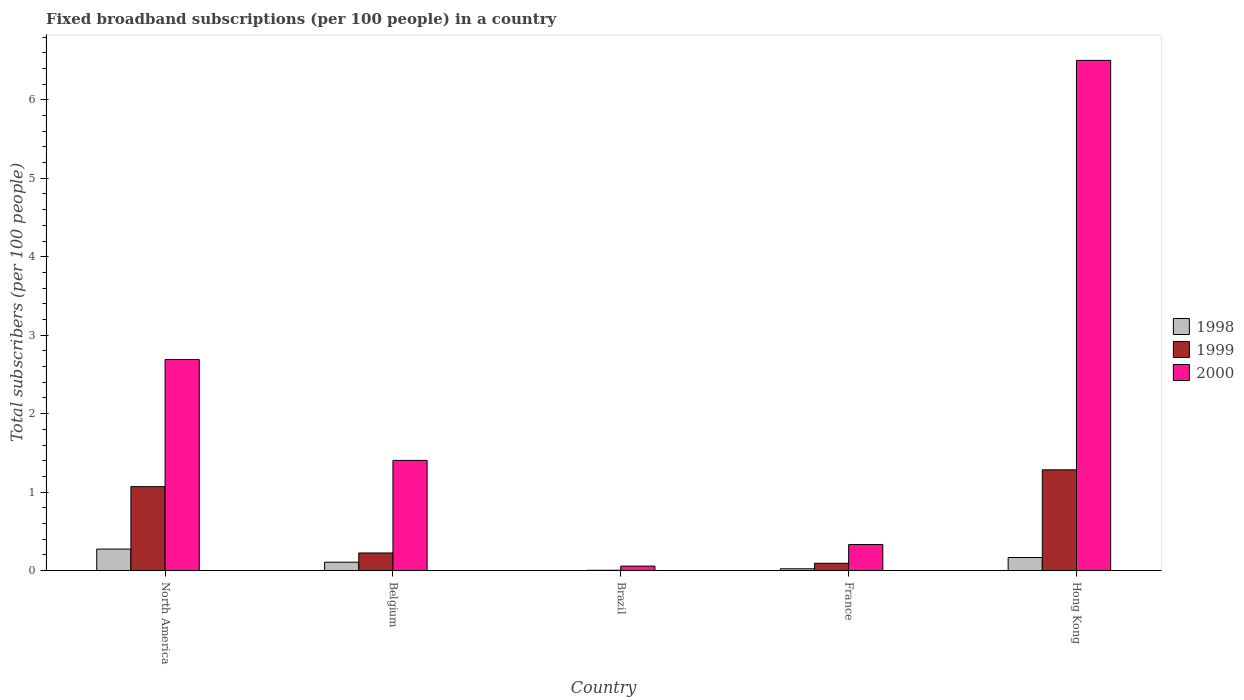How many different coloured bars are there?
Provide a short and direct response. 3. Are the number of bars per tick equal to the number of legend labels?
Your response must be concise. Yes. How many bars are there on the 4th tick from the left?
Your answer should be compact. 3. How many bars are there on the 4th tick from the right?
Provide a succinct answer. 3. What is the label of the 5th group of bars from the left?
Ensure brevity in your answer.  Hong Kong. In how many cases, is the number of bars for a given country not equal to the number of legend labels?
Ensure brevity in your answer.  0. What is the number of broadband subscriptions in 1999 in France?
Your answer should be very brief. 0.09. Across all countries, what is the maximum number of broadband subscriptions in 1998?
Your response must be concise. 0.27. Across all countries, what is the minimum number of broadband subscriptions in 2000?
Your response must be concise. 0.06. In which country was the number of broadband subscriptions in 1999 maximum?
Ensure brevity in your answer.  Hong Kong. What is the total number of broadband subscriptions in 1999 in the graph?
Make the answer very short. 2.68. What is the difference between the number of broadband subscriptions in 1998 in Belgium and that in North America?
Give a very brief answer. -0.17. What is the difference between the number of broadband subscriptions in 1998 in France and the number of broadband subscriptions in 2000 in Hong Kong?
Give a very brief answer. -6.48. What is the average number of broadband subscriptions in 2000 per country?
Give a very brief answer. 2.2. What is the difference between the number of broadband subscriptions of/in 1998 and number of broadband subscriptions of/in 1999 in North America?
Offer a terse response. -0.8. What is the ratio of the number of broadband subscriptions in 1998 in France to that in Hong Kong?
Provide a short and direct response. 0.14. Is the number of broadband subscriptions in 1999 in Belgium less than that in Brazil?
Offer a very short reply. No. What is the difference between the highest and the second highest number of broadband subscriptions in 2000?
Your response must be concise. -1.29. What is the difference between the highest and the lowest number of broadband subscriptions in 1999?
Keep it short and to the point. 1.28. What does the 2nd bar from the left in Hong Kong represents?
Provide a succinct answer. 1999. How many bars are there?
Your answer should be compact. 15. Are all the bars in the graph horizontal?
Ensure brevity in your answer.  No. How many countries are there in the graph?
Provide a short and direct response. 5. Does the graph contain grids?
Ensure brevity in your answer.  No. Where does the legend appear in the graph?
Provide a short and direct response. Center right. What is the title of the graph?
Your answer should be compact. Fixed broadband subscriptions (per 100 people) in a country. Does "1969" appear as one of the legend labels in the graph?
Keep it short and to the point. No. What is the label or title of the X-axis?
Offer a terse response. Country. What is the label or title of the Y-axis?
Your response must be concise. Total subscribers (per 100 people). What is the Total subscribers (per 100 people) in 1998 in North America?
Offer a very short reply. 0.27. What is the Total subscribers (per 100 people) of 1999 in North America?
Your answer should be very brief. 1.07. What is the Total subscribers (per 100 people) of 2000 in North America?
Your answer should be very brief. 2.69. What is the Total subscribers (per 100 people) in 1998 in Belgium?
Ensure brevity in your answer.  0.11. What is the Total subscribers (per 100 people) of 1999 in Belgium?
Your answer should be very brief. 0.22. What is the Total subscribers (per 100 people) of 2000 in Belgium?
Provide a short and direct response. 1.4. What is the Total subscribers (per 100 people) of 1998 in Brazil?
Your answer should be very brief. 0. What is the Total subscribers (per 100 people) in 1999 in Brazil?
Keep it short and to the point. 0. What is the Total subscribers (per 100 people) of 2000 in Brazil?
Your answer should be compact. 0.06. What is the Total subscribers (per 100 people) in 1998 in France?
Offer a very short reply. 0.02. What is the Total subscribers (per 100 people) in 1999 in France?
Offer a very short reply. 0.09. What is the Total subscribers (per 100 people) of 2000 in France?
Offer a terse response. 0.33. What is the Total subscribers (per 100 people) in 1998 in Hong Kong?
Ensure brevity in your answer.  0.17. What is the Total subscribers (per 100 people) in 1999 in Hong Kong?
Ensure brevity in your answer.  1.28. What is the Total subscribers (per 100 people) of 2000 in Hong Kong?
Provide a succinct answer. 6.5. Across all countries, what is the maximum Total subscribers (per 100 people) in 1998?
Give a very brief answer. 0.27. Across all countries, what is the maximum Total subscribers (per 100 people) in 1999?
Ensure brevity in your answer.  1.28. Across all countries, what is the maximum Total subscribers (per 100 people) in 2000?
Keep it short and to the point. 6.5. Across all countries, what is the minimum Total subscribers (per 100 people) in 1998?
Ensure brevity in your answer.  0. Across all countries, what is the minimum Total subscribers (per 100 people) of 1999?
Provide a short and direct response. 0. Across all countries, what is the minimum Total subscribers (per 100 people) in 2000?
Offer a terse response. 0.06. What is the total Total subscribers (per 100 people) of 1998 in the graph?
Offer a very short reply. 0.57. What is the total Total subscribers (per 100 people) in 1999 in the graph?
Your answer should be compact. 2.68. What is the total Total subscribers (per 100 people) of 2000 in the graph?
Provide a short and direct response. 10.99. What is the difference between the Total subscribers (per 100 people) in 1998 in North America and that in Belgium?
Provide a succinct answer. 0.17. What is the difference between the Total subscribers (per 100 people) of 1999 in North America and that in Belgium?
Make the answer very short. 0.85. What is the difference between the Total subscribers (per 100 people) of 2000 in North America and that in Belgium?
Make the answer very short. 1.29. What is the difference between the Total subscribers (per 100 people) in 1998 in North America and that in Brazil?
Your response must be concise. 0.27. What is the difference between the Total subscribers (per 100 people) of 1999 in North America and that in Brazil?
Provide a short and direct response. 1.07. What is the difference between the Total subscribers (per 100 people) of 2000 in North America and that in Brazil?
Your answer should be compact. 2.63. What is the difference between the Total subscribers (per 100 people) in 1998 in North America and that in France?
Give a very brief answer. 0.25. What is the difference between the Total subscribers (per 100 people) in 1999 in North America and that in France?
Your answer should be compact. 0.98. What is the difference between the Total subscribers (per 100 people) in 2000 in North America and that in France?
Ensure brevity in your answer.  2.36. What is the difference between the Total subscribers (per 100 people) in 1998 in North America and that in Hong Kong?
Give a very brief answer. 0.11. What is the difference between the Total subscribers (per 100 people) of 1999 in North America and that in Hong Kong?
Keep it short and to the point. -0.21. What is the difference between the Total subscribers (per 100 people) of 2000 in North America and that in Hong Kong?
Offer a terse response. -3.81. What is the difference between the Total subscribers (per 100 people) in 1998 in Belgium and that in Brazil?
Your answer should be compact. 0.11. What is the difference between the Total subscribers (per 100 people) in 1999 in Belgium and that in Brazil?
Ensure brevity in your answer.  0.22. What is the difference between the Total subscribers (per 100 people) in 2000 in Belgium and that in Brazil?
Your answer should be compact. 1.35. What is the difference between the Total subscribers (per 100 people) in 1998 in Belgium and that in France?
Ensure brevity in your answer.  0.08. What is the difference between the Total subscribers (per 100 people) of 1999 in Belgium and that in France?
Your answer should be compact. 0.13. What is the difference between the Total subscribers (per 100 people) of 2000 in Belgium and that in France?
Your answer should be very brief. 1.07. What is the difference between the Total subscribers (per 100 people) of 1998 in Belgium and that in Hong Kong?
Make the answer very short. -0.06. What is the difference between the Total subscribers (per 100 people) of 1999 in Belgium and that in Hong Kong?
Give a very brief answer. -1.06. What is the difference between the Total subscribers (per 100 people) of 2000 in Belgium and that in Hong Kong?
Provide a succinct answer. -5.1. What is the difference between the Total subscribers (per 100 people) in 1998 in Brazil and that in France?
Your response must be concise. -0.02. What is the difference between the Total subscribers (per 100 people) in 1999 in Brazil and that in France?
Provide a succinct answer. -0.09. What is the difference between the Total subscribers (per 100 people) in 2000 in Brazil and that in France?
Ensure brevity in your answer.  -0.27. What is the difference between the Total subscribers (per 100 people) of 1998 in Brazil and that in Hong Kong?
Provide a short and direct response. -0.17. What is the difference between the Total subscribers (per 100 people) of 1999 in Brazil and that in Hong Kong?
Your answer should be compact. -1.28. What is the difference between the Total subscribers (per 100 people) of 2000 in Brazil and that in Hong Kong?
Your response must be concise. -6.45. What is the difference between the Total subscribers (per 100 people) in 1998 in France and that in Hong Kong?
Your response must be concise. -0.14. What is the difference between the Total subscribers (per 100 people) in 1999 in France and that in Hong Kong?
Give a very brief answer. -1.19. What is the difference between the Total subscribers (per 100 people) in 2000 in France and that in Hong Kong?
Offer a terse response. -6.17. What is the difference between the Total subscribers (per 100 people) of 1998 in North America and the Total subscribers (per 100 people) of 1999 in Belgium?
Provide a short and direct response. 0.05. What is the difference between the Total subscribers (per 100 people) of 1998 in North America and the Total subscribers (per 100 people) of 2000 in Belgium?
Your answer should be compact. -1.13. What is the difference between the Total subscribers (per 100 people) of 1999 in North America and the Total subscribers (per 100 people) of 2000 in Belgium?
Ensure brevity in your answer.  -0.33. What is the difference between the Total subscribers (per 100 people) in 1998 in North America and the Total subscribers (per 100 people) in 1999 in Brazil?
Keep it short and to the point. 0.27. What is the difference between the Total subscribers (per 100 people) of 1998 in North America and the Total subscribers (per 100 people) of 2000 in Brazil?
Make the answer very short. 0.22. What is the difference between the Total subscribers (per 100 people) of 1999 in North America and the Total subscribers (per 100 people) of 2000 in Brazil?
Provide a short and direct response. 1.01. What is the difference between the Total subscribers (per 100 people) of 1998 in North America and the Total subscribers (per 100 people) of 1999 in France?
Provide a short and direct response. 0.18. What is the difference between the Total subscribers (per 100 people) of 1998 in North America and the Total subscribers (per 100 people) of 2000 in France?
Your answer should be very brief. -0.06. What is the difference between the Total subscribers (per 100 people) in 1999 in North America and the Total subscribers (per 100 people) in 2000 in France?
Make the answer very short. 0.74. What is the difference between the Total subscribers (per 100 people) in 1998 in North America and the Total subscribers (per 100 people) in 1999 in Hong Kong?
Offer a very short reply. -1.01. What is the difference between the Total subscribers (per 100 people) in 1998 in North America and the Total subscribers (per 100 people) in 2000 in Hong Kong?
Keep it short and to the point. -6.23. What is the difference between the Total subscribers (per 100 people) of 1999 in North America and the Total subscribers (per 100 people) of 2000 in Hong Kong?
Ensure brevity in your answer.  -5.43. What is the difference between the Total subscribers (per 100 people) in 1998 in Belgium and the Total subscribers (per 100 people) in 1999 in Brazil?
Give a very brief answer. 0.1. What is the difference between the Total subscribers (per 100 people) in 1998 in Belgium and the Total subscribers (per 100 people) in 2000 in Brazil?
Your answer should be very brief. 0.05. What is the difference between the Total subscribers (per 100 people) of 1999 in Belgium and the Total subscribers (per 100 people) of 2000 in Brazil?
Your response must be concise. 0.17. What is the difference between the Total subscribers (per 100 people) in 1998 in Belgium and the Total subscribers (per 100 people) in 1999 in France?
Offer a very short reply. 0.01. What is the difference between the Total subscribers (per 100 people) in 1998 in Belgium and the Total subscribers (per 100 people) in 2000 in France?
Make the answer very short. -0.23. What is the difference between the Total subscribers (per 100 people) in 1999 in Belgium and the Total subscribers (per 100 people) in 2000 in France?
Ensure brevity in your answer.  -0.11. What is the difference between the Total subscribers (per 100 people) in 1998 in Belgium and the Total subscribers (per 100 people) in 1999 in Hong Kong?
Offer a very short reply. -1.18. What is the difference between the Total subscribers (per 100 people) of 1998 in Belgium and the Total subscribers (per 100 people) of 2000 in Hong Kong?
Give a very brief answer. -6.4. What is the difference between the Total subscribers (per 100 people) in 1999 in Belgium and the Total subscribers (per 100 people) in 2000 in Hong Kong?
Your answer should be compact. -6.28. What is the difference between the Total subscribers (per 100 people) in 1998 in Brazil and the Total subscribers (per 100 people) in 1999 in France?
Provide a short and direct response. -0.09. What is the difference between the Total subscribers (per 100 people) in 1998 in Brazil and the Total subscribers (per 100 people) in 2000 in France?
Your response must be concise. -0.33. What is the difference between the Total subscribers (per 100 people) of 1999 in Brazil and the Total subscribers (per 100 people) of 2000 in France?
Offer a very short reply. -0.33. What is the difference between the Total subscribers (per 100 people) of 1998 in Brazil and the Total subscribers (per 100 people) of 1999 in Hong Kong?
Give a very brief answer. -1.28. What is the difference between the Total subscribers (per 100 people) of 1998 in Brazil and the Total subscribers (per 100 people) of 2000 in Hong Kong?
Make the answer very short. -6.5. What is the difference between the Total subscribers (per 100 people) of 1999 in Brazil and the Total subscribers (per 100 people) of 2000 in Hong Kong?
Offer a very short reply. -6.5. What is the difference between the Total subscribers (per 100 people) of 1998 in France and the Total subscribers (per 100 people) of 1999 in Hong Kong?
Keep it short and to the point. -1.26. What is the difference between the Total subscribers (per 100 people) in 1998 in France and the Total subscribers (per 100 people) in 2000 in Hong Kong?
Offer a very short reply. -6.48. What is the difference between the Total subscribers (per 100 people) of 1999 in France and the Total subscribers (per 100 people) of 2000 in Hong Kong?
Ensure brevity in your answer.  -6.41. What is the average Total subscribers (per 100 people) of 1998 per country?
Provide a short and direct response. 0.11. What is the average Total subscribers (per 100 people) in 1999 per country?
Your answer should be compact. 0.54. What is the average Total subscribers (per 100 people) of 2000 per country?
Your answer should be compact. 2.2. What is the difference between the Total subscribers (per 100 people) in 1998 and Total subscribers (per 100 people) in 1999 in North America?
Provide a short and direct response. -0.8. What is the difference between the Total subscribers (per 100 people) of 1998 and Total subscribers (per 100 people) of 2000 in North America?
Give a very brief answer. -2.42. What is the difference between the Total subscribers (per 100 people) in 1999 and Total subscribers (per 100 people) in 2000 in North America?
Offer a terse response. -1.62. What is the difference between the Total subscribers (per 100 people) of 1998 and Total subscribers (per 100 people) of 1999 in Belgium?
Your answer should be compact. -0.12. What is the difference between the Total subscribers (per 100 people) in 1998 and Total subscribers (per 100 people) in 2000 in Belgium?
Provide a succinct answer. -1.3. What is the difference between the Total subscribers (per 100 people) in 1999 and Total subscribers (per 100 people) in 2000 in Belgium?
Keep it short and to the point. -1.18. What is the difference between the Total subscribers (per 100 people) in 1998 and Total subscribers (per 100 people) in 1999 in Brazil?
Your answer should be compact. -0. What is the difference between the Total subscribers (per 100 people) of 1998 and Total subscribers (per 100 people) of 2000 in Brazil?
Keep it short and to the point. -0.06. What is the difference between the Total subscribers (per 100 people) in 1999 and Total subscribers (per 100 people) in 2000 in Brazil?
Your answer should be compact. -0.05. What is the difference between the Total subscribers (per 100 people) of 1998 and Total subscribers (per 100 people) of 1999 in France?
Ensure brevity in your answer.  -0.07. What is the difference between the Total subscribers (per 100 people) in 1998 and Total subscribers (per 100 people) in 2000 in France?
Your answer should be compact. -0.31. What is the difference between the Total subscribers (per 100 people) of 1999 and Total subscribers (per 100 people) of 2000 in France?
Provide a short and direct response. -0.24. What is the difference between the Total subscribers (per 100 people) of 1998 and Total subscribers (per 100 people) of 1999 in Hong Kong?
Your answer should be compact. -1.12. What is the difference between the Total subscribers (per 100 people) of 1998 and Total subscribers (per 100 people) of 2000 in Hong Kong?
Your answer should be very brief. -6.34. What is the difference between the Total subscribers (per 100 people) of 1999 and Total subscribers (per 100 people) of 2000 in Hong Kong?
Provide a short and direct response. -5.22. What is the ratio of the Total subscribers (per 100 people) in 1998 in North America to that in Belgium?
Your answer should be very brief. 2.57. What is the ratio of the Total subscribers (per 100 people) of 1999 in North America to that in Belgium?
Offer a very short reply. 4.76. What is the ratio of the Total subscribers (per 100 people) of 2000 in North America to that in Belgium?
Make the answer very short. 1.92. What is the ratio of the Total subscribers (per 100 people) of 1998 in North America to that in Brazil?
Make the answer very short. 465.15. What is the ratio of the Total subscribers (per 100 people) of 1999 in North America to that in Brazil?
Your answer should be very brief. 262.9. What is the ratio of the Total subscribers (per 100 people) in 2000 in North America to that in Brazil?
Provide a succinct answer. 46.94. What is the ratio of the Total subscribers (per 100 people) of 1998 in North America to that in France?
Ensure brevity in your answer.  11.95. What is the ratio of the Total subscribers (per 100 people) of 1999 in North America to that in France?
Your answer should be compact. 11.46. What is the ratio of the Total subscribers (per 100 people) of 2000 in North America to that in France?
Keep it short and to the point. 8.1. What is the ratio of the Total subscribers (per 100 people) of 1998 in North America to that in Hong Kong?
Make the answer very short. 1.64. What is the ratio of the Total subscribers (per 100 people) in 1999 in North America to that in Hong Kong?
Your answer should be compact. 0.83. What is the ratio of the Total subscribers (per 100 people) in 2000 in North America to that in Hong Kong?
Make the answer very short. 0.41. What is the ratio of the Total subscribers (per 100 people) of 1998 in Belgium to that in Brazil?
Offer a terse response. 181.1. What is the ratio of the Total subscribers (per 100 people) in 1999 in Belgium to that in Brazil?
Your answer should be very brief. 55.18. What is the ratio of the Total subscribers (per 100 people) in 2000 in Belgium to that in Brazil?
Your response must be concise. 24.51. What is the ratio of the Total subscribers (per 100 people) of 1998 in Belgium to that in France?
Your response must be concise. 4.65. What is the ratio of the Total subscribers (per 100 people) in 1999 in Belgium to that in France?
Your answer should be very brief. 2.4. What is the ratio of the Total subscribers (per 100 people) of 2000 in Belgium to that in France?
Your answer should be compact. 4.23. What is the ratio of the Total subscribers (per 100 people) in 1998 in Belgium to that in Hong Kong?
Provide a short and direct response. 0.64. What is the ratio of the Total subscribers (per 100 people) of 1999 in Belgium to that in Hong Kong?
Give a very brief answer. 0.17. What is the ratio of the Total subscribers (per 100 people) in 2000 in Belgium to that in Hong Kong?
Give a very brief answer. 0.22. What is the ratio of the Total subscribers (per 100 people) of 1998 in Brazil to that in France?
Make the answer very short. 0.03. What is the ratio of the Total subscribers (per 100 people) of 1999 in Brazil to that in France?
Your answer should be compact. 0.04. What is the ratio of the Total subscribers (per 100 people) of 2000 in Brazil to that in France?
Provide a succinct answer. 0.17. What is the ratio of the Total subscribers (per 100 people) of 1998 in Brazil to that in Hong Kong?
Your response must be concise. 0. What is the ratio of the Total subscribers (per 100 people) in 1999 in Brazil to that in Hong Kong?
Your response must be concise. 0. What is the ratio of the Total subscribers (per 100 people) in 2000 in Brazil to that in Hong Kong?
Offer a very short reply. 0.01. What is the ratio of the Total subscribers (per 100 people) of 1998 in France to that in Hong Kong?
Ensure brevity in your answer.  0.14. What is the ratio of the Total subscribers (per 100 people) in 1999 in France to that in Hong Kong?
Your answer should be compact. 0.07. What is the ratio of the Total subscribers (per 100 people) of 2000 in France to that in Hong Kong?
Your answer should be very brief. 0.05. What is the difference between the highest and the second highest Total subscribers (per 100 people) of 1998?
Keep it short and to the point. 0.11. What is the difference between the highest and the second highest Total subscribers (per 100 people) of 1999?
Keep it short and to the point. 0.21. What is the difference between the highest and the second highest Total subscribers (per 100 people) of 2000?
Ensure brevity in your answer.  3.81. What is the difference between the highest and the lowest Total subscribers (per 100 people) of 1998?
Offer a terse response. 0.27. What is the difference between the highest and the lowest Total subscribers (per 100 people) of 1999?
Make the answer very short. 1.28. What is the difference between the highest and the lowest Total subscribers (per 100 people) in 2000?
Your answer should be compact. 6.45. 